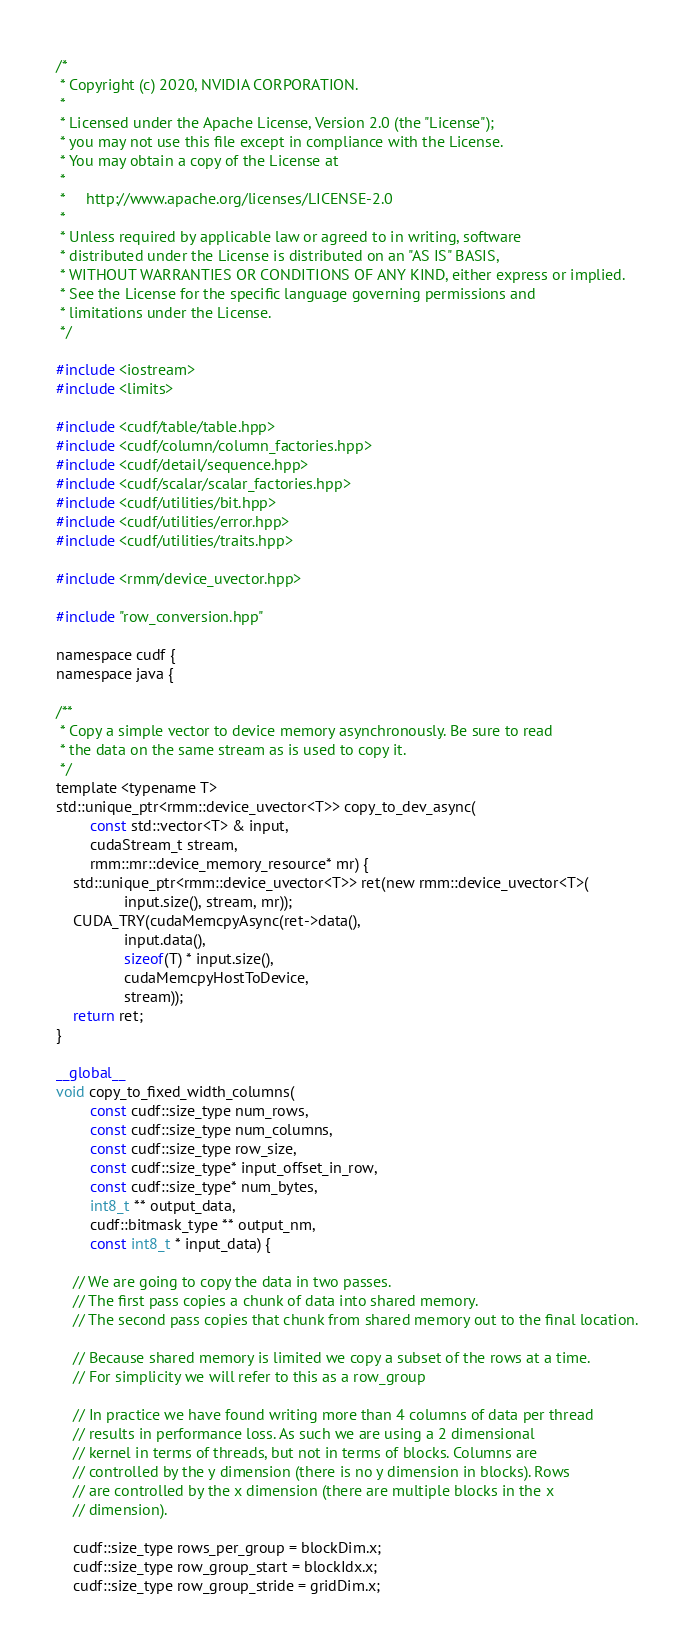Convert code to text. <code><loc_0><loc_0><loc_500><loc_500><_Cuda_>/*
 * Copyright (c) 2020, NVIDIA CORPORATION.
 *
 * Licensed under the Apache License, Version 2.0 (the "License");
 * you may not use this file except in compliance with the License.
 * You may obtain a copy of the License at
 *
 *     http://www.apache.org/licenses/LICENSE-2.0
 *
 * Unless required by applicable law or agreed to in writing, software
 * distributed under the License is distributed on an "AS IS" BASIS,
 * WITHOUT WARRANTIES OR CONDITIONS OF ANY KIND, either express or implied.
 * See the License for the specific language governing permissions and
 * limitations under the License.
 */

#include <iostream>
#include <limits>

#include <cudf/table/table.hpp>
#include <cudf/column/column_factories.hpp>
#include <cudf/detail/sequence.hpp>
#include <cudf/scalar/scalar_factories.hpp>
#include <cudf/utilities/bit.hpp>
#include <cudf/utilities/error.hpp>
#include <cudf/utilities/traits.hpp>

#include <rmm/device_uvector.hpp>

#include "row_conversion.hpp"

namespace cudf {
namespace java {

/**
 * Copy a simple vector to device memory asynchronously. Be sure to read
 * the data on the same stream as is used to copy it.
 */
template <typename T>
std::unique_ptr<rmm::device_uvector<T>> copy_to_dev_async(
        const std::vector<T> & input,
        cudaStream_t stream,
        rmm::mr::device_memory_resource* mr) {
    std::unique_ptr<rmm::device_uvector<T>> ret(new rmm::device_uvector<T>(
                input.size(), stream, mr));
    CUDA_TRY(cudaMemcpyAsync(ret->data(),
                input.data(),
                sizeof(T) * input.size(),
                cudaMemcpyHostToDevice,
                stream));
    return ret;
}

__global__
void copy_to_fixed_width_columns(
        const cudf::size_type num_rows,
        const cudf::size_type num_columns,
        const cudf::size_type row_size,
        const cudf::size_type* input_offset_in_row,
        const cudf::size_type* num_bytes,
        int8_t ** output_data,
        cudf::bitmask_type ** output_nm,
        const int8_t * input_data) {

    // We are going to copy the data in two passes.
    // The first pass copies a chunk of data into shared memory.
    // The second pass copies that chunk from shared memory out to the final location.
    
    // Because shared memory is limited we copy a subset of the rows at a time.
    // For simplicity we will refer to this as a row_group

    // In practice we have found writing more than 4 columns of data per thread
    // results in performance loss. As such we are using a 2 dimensional
    // kernel in terms of threads, but not in terms of blocks. Columns are
    // controlled by the y dimension (there is no y dimension in blocks). Rows
    // are controlled by the x dimension (there are multiple blocks in the x
    // dimension).

    cudf::size_type rows_per_group = blockDim.x;
    cudf::size_type row_group_start = blockIdx.x;
    cudf::size_type row_group_stride = gridDim.x;</code> 